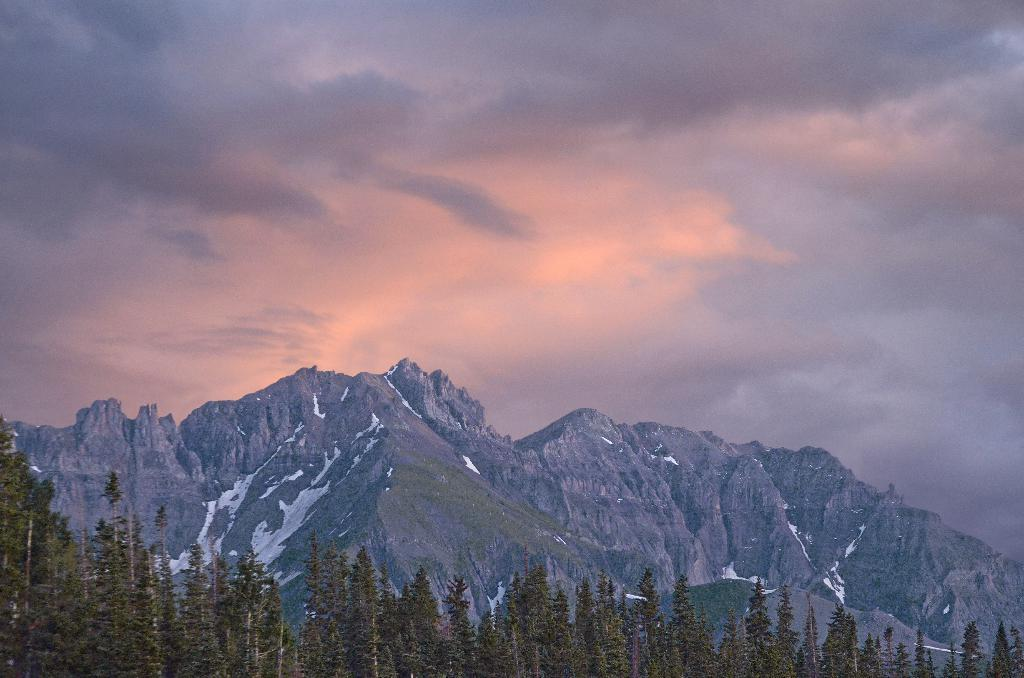What type of natural formation can be seen in the image? There are mountains in the image. What other natural elements are present in the image? There are trees in the image. Can you describe the condition of the mountains? There might be snow on the mountains. What is visible at the top of the image? The sky is visible at the top of the image. What can be seen in the sky? There are clouds in the sky. What type of nerve is responsible for the invention of brass in the image? There is no mention of nerves, inventions, or brass in the image; it features mountains, trees, and clouds. 